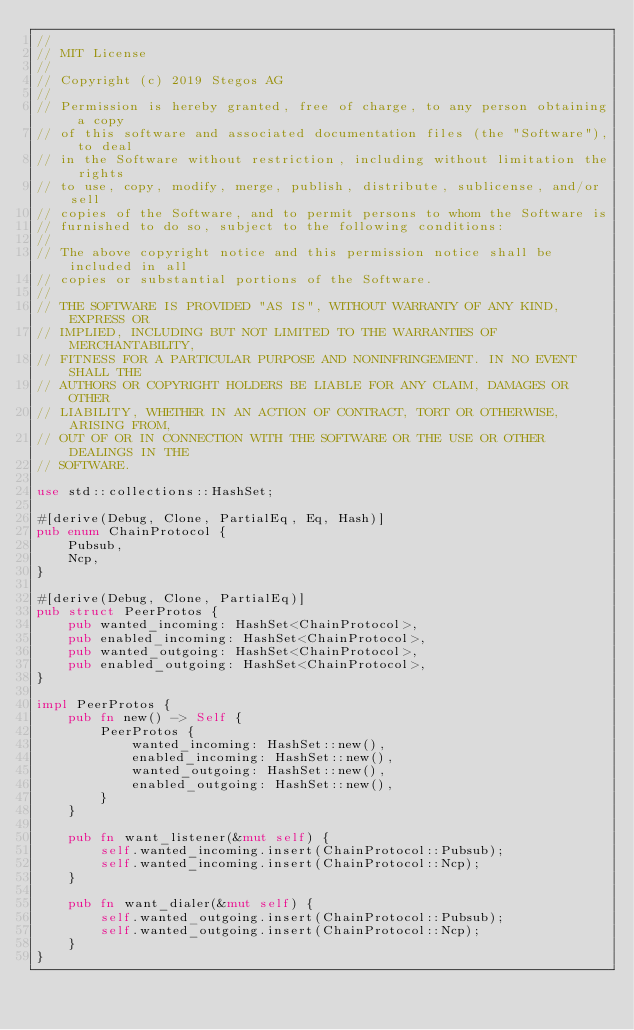<code> <loc_0><loc_0><loc_500><loc_500><_Rust_>//
// MIT License
//
// Copyright (c) 2019 Stegos AG
//
// Permission is hereby granted, free of charge, to any person obtaining a copy
// of this software and associated documentation files (the "Software"), to deal
// in the Software without restriction, including without limitation the rights
// to use, copy, modify, merge, publish, distribute, sublicense, and/or sell
// copies of the Software, and to permit persons to whom the Software is
// furnished to do so, subject to the following conditions:
//
// The above copyright notice and this permission notice shall be included in all
// copies or substantial portions of the Software.
//
// THE SOFTWARE IS PROVIDED "AS IS", WITHOUT WARRANTY OF ANY KIND, EXPRESS OR
// IMPLIED, INCLUDING BUT NOT LIMITED TO THE WARRANTIES OF MERCHANTABILITY,
// FITNESS FOR A PARTICULAR PURPOSE AND NONINFRINGEMENT. IN NO EVENT SHALL THE
// AUTHORS OR COPYRIGHT HOLDERS BE LIABLE FOR ANY CLAIM, DAMAGES OR OTHER
// LIABILITY, WHETHER IN AN ACTION OF CONTRACT, TORT OR OTHERWISE, ARISING FROM,
// OUT OF OR IN CONNECTION WITH THE SOFTWARE OR THE USE OR OTHER DEALINGS IN THE
// SOFTWARE.

use std::collections::HashSet;

#[derive(Debug, Clone, PartialEq, Eq, Hash)]
pub enum ChainProtocol {
    Pubsub,
    Ncp,
}

#[derive(Debug, Clone, PartialEq)]
pub struct PeerProtos {
    pub wanted_incoming: HashSet<ChainProtocol>,
    pub enabled_incoming: HashSet<ChainProtocol>,
    pub wanted_outgoing: HashSet<ChainProtocol>,
    pub enabled_outgoing: HashSet<ChainProtocol>,
}

impl PeerProtos {
    pub fn new() -> Self {
        PeerProtos {
            wanted_incoming: HashSet::new(),
            enabled_incoming: HashSet::new(),
            wanted_outgoing: HashSet::new(),
            enabled_outgoing: HashSet::new(),
        }
    }

    pub fn want_listener(&mut self) {
        self.wanted_incoming.insert(ChainProtocol::Pubsub);
        self.wanted_incoming.insert(ChainProtocol::Ncp);
    }

    pub fn want_dialer(&mut self) {
        self.wanted_outgoing.insert(ChainProtocol::Pubsub);
        self.wanted_outgoing.insert(ChainProtocol::Ncp);
    }
}
</code> 